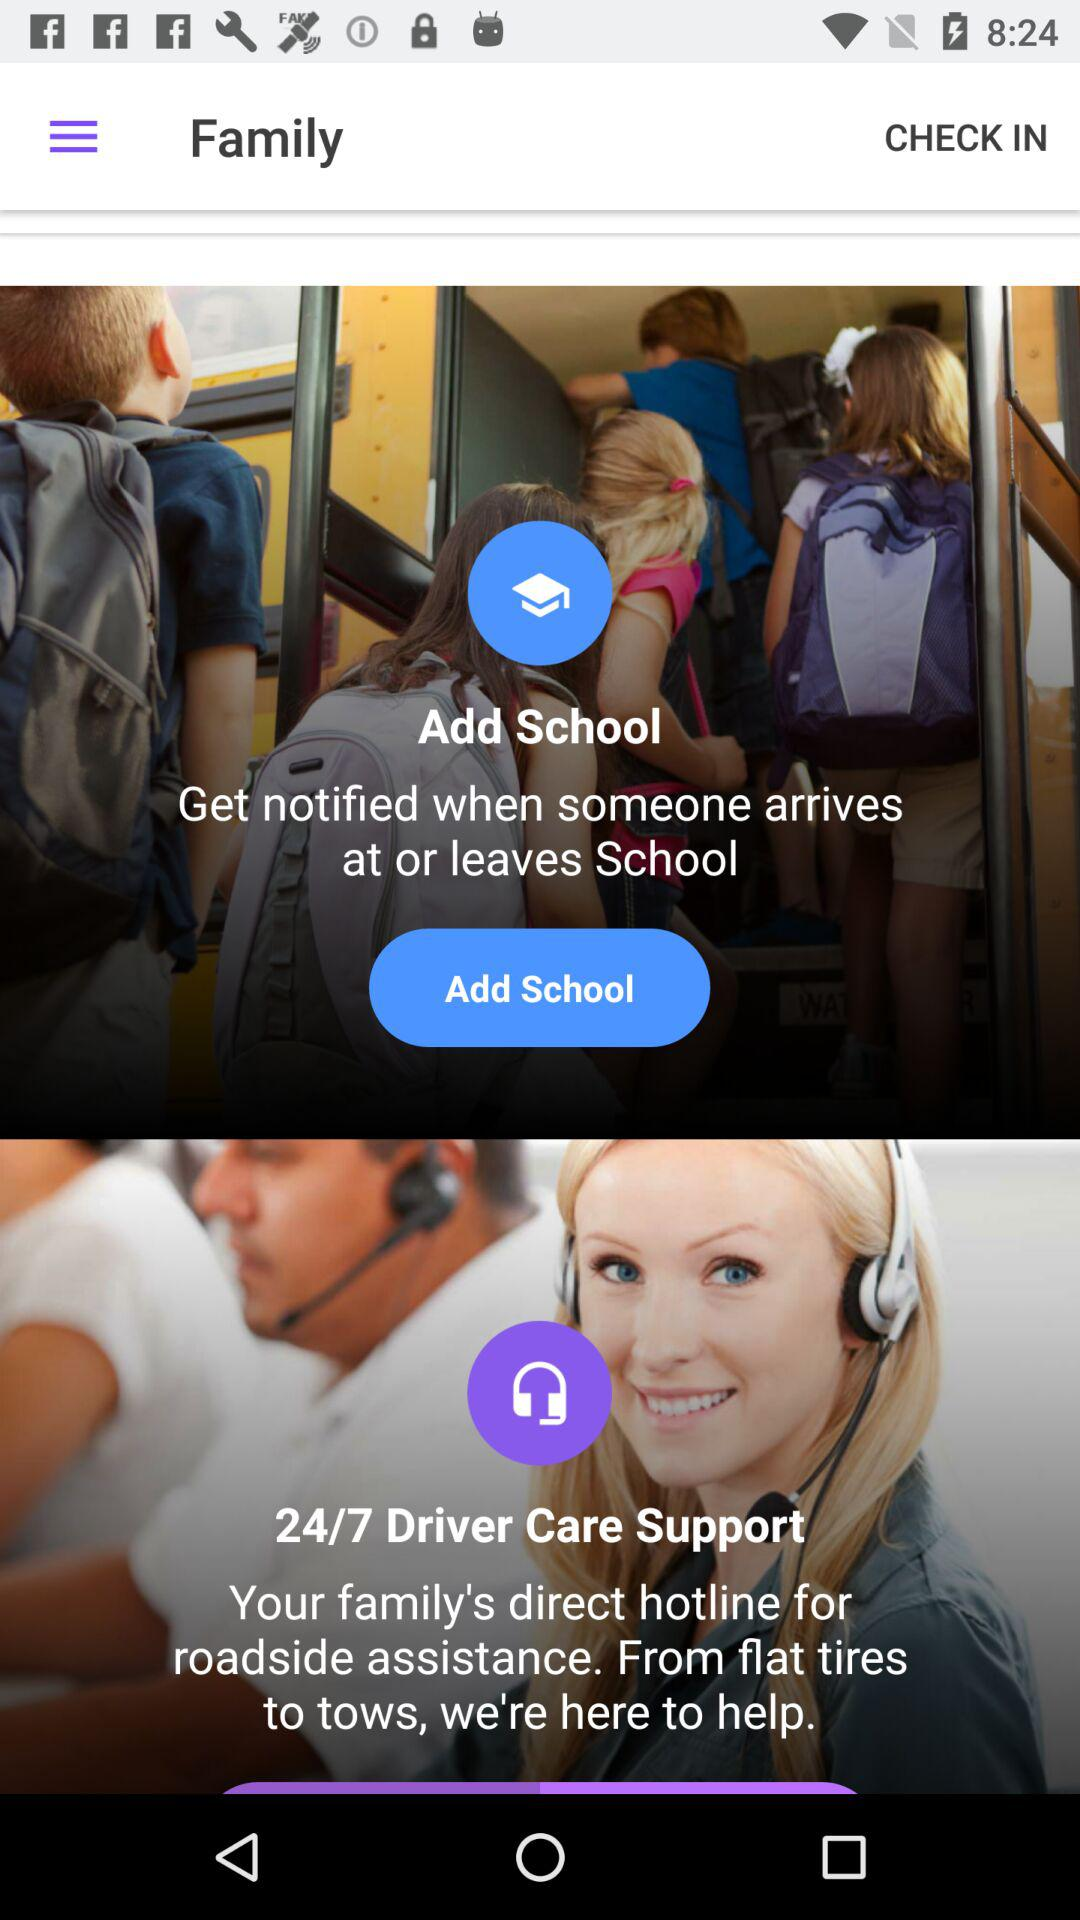How many hours a day is "Driver Care Support" open? It is open 24 hours a day. 